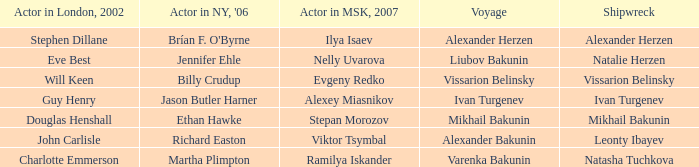Who was the actor in London in 2002 with the shipwreck of Leonty Ibayev? John Carlisle. 